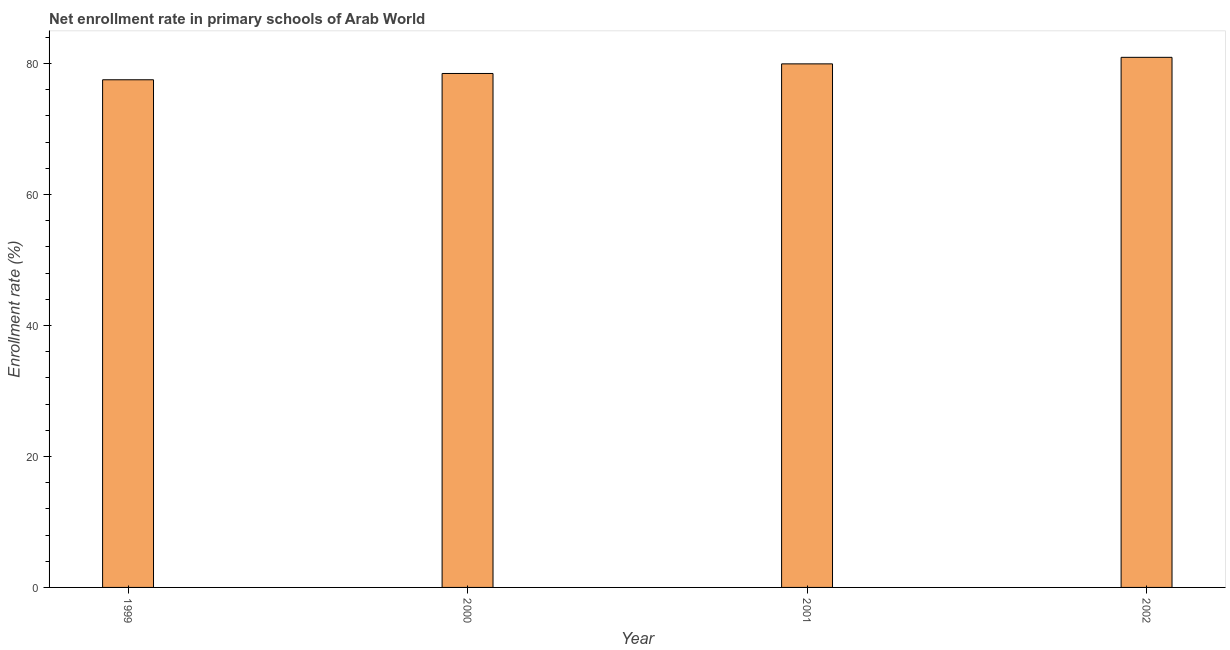What is the title of the graph?
Provide a short and direct response. Net enrollment rate in primary schools of Arab World. What is the label or title of the Y-axis?
Your answer should be very brief. Enrollment rate (%). What is the net enrollment rate in primary schools in 2001?
Offer a terse response. 79.96. Across all years, what is the maximum net enrollment rate in primary schools?
Ensure brevity in your answer.  80.95. Across all years, what is the minimum net enrollment rate in primary schools?
Ensure brevity in your answer.  77.53. In which year was the net enrollment rate in primary schools maximum?
Offer a very short reply. 2002. What is the sum of the net enrollment rate in primary schools?
Offer a terse response. 316.93. What is the difference between the net enrollment rate in primary schools in 1999 and 2001?
Your answer should be very brief. -2.43. What is the average net enrollment rate in primary schools per year?
Provide a succinct answer. 79.23. What is the median net enrollment rate in primary schools?
Give a very brief answer. 79.22. Do a majority of the years between 2002 and 2000 (inclusive) have net enrollment rate in primary schools greater than 72 %?
Provide a succinct answer. Yes. What is the ratio of the net enrollment rate in primary schools in 1999 to that in 2000?
Your answer should be very brief. 0.99. Is the net enrollment rate in primary schools in 2000 less than that in 2002?
Make the answer very short. Yes. Is the difference between the net enrollment rate in primary schools in 1999 and 2002 greater than the difference between any two years?
Keep it short and to the point. Yes. What is the difference between the highest and the second highest net enrollment rate in primary schools?
Offer a terse response. 1. Is the sum of the net enrollment rate in primary schools in 2001 and 2002 greater than the maximum net enrollment rate in primary schools across all years?
Give a very brief answer. Yes. What is the difference between the highest and the lowest net enrollment rate in primary schools?
Your answer should be very brief. 3.43. How many bars are there?
Provide a short and direct response. 4. Are all the bars in the graph horizontal?
Give a very brief answer. No. Are the values on the major ticks of Y-axis written in scientific E-notation?
Give a very brief answer. No. What is the Enrollment rate (%) of 1999?
Provide a short and direct response. 77.53. What is the Enrollment rate (%) in 2000?
Your response must be concise. 78.49. What is the Enrollment rate (%) of 2001?
Keep it short and to the point. 79.96. What is the Enrollment rate (%) in 2002?
Ensure brevity in your answer.  80.95. What is the difference between the Enrollment rate (%) in 1999 and 2000?
Provide a short and direct response. -0.96. What is the difference between the Enrollment rate (%) in 1999 and 2001?
Make the answer very short. -2.43. What is the difference between the Enrollment rate (%) in 1999 and 2002?
Your answer should be compact. -3.43. What is the difference between the Enrollment rate (%) in 2000 and 2001?
Offer a terse response. -1.47. What is the difference between the Enrollment rate (%) in 2000 and 2002?
Offer a very short reply. -2.47. What is the difference between the Enrollment rate (%) in 2001 and 2002?
Your answer should be very brief. -1. What is the ratio of the Enrollment rate (%) in 1999 to that in 2001?
Make the answer very short. 0.97. What is the ratio of the Enrollment rate (%) in 1999 to that in 2002?
Offer a terse response. 0.96. What is the ratio of the Enrollment rate (%) in 2000 to that in 2001?
Give a very brief answer. 0.98. 